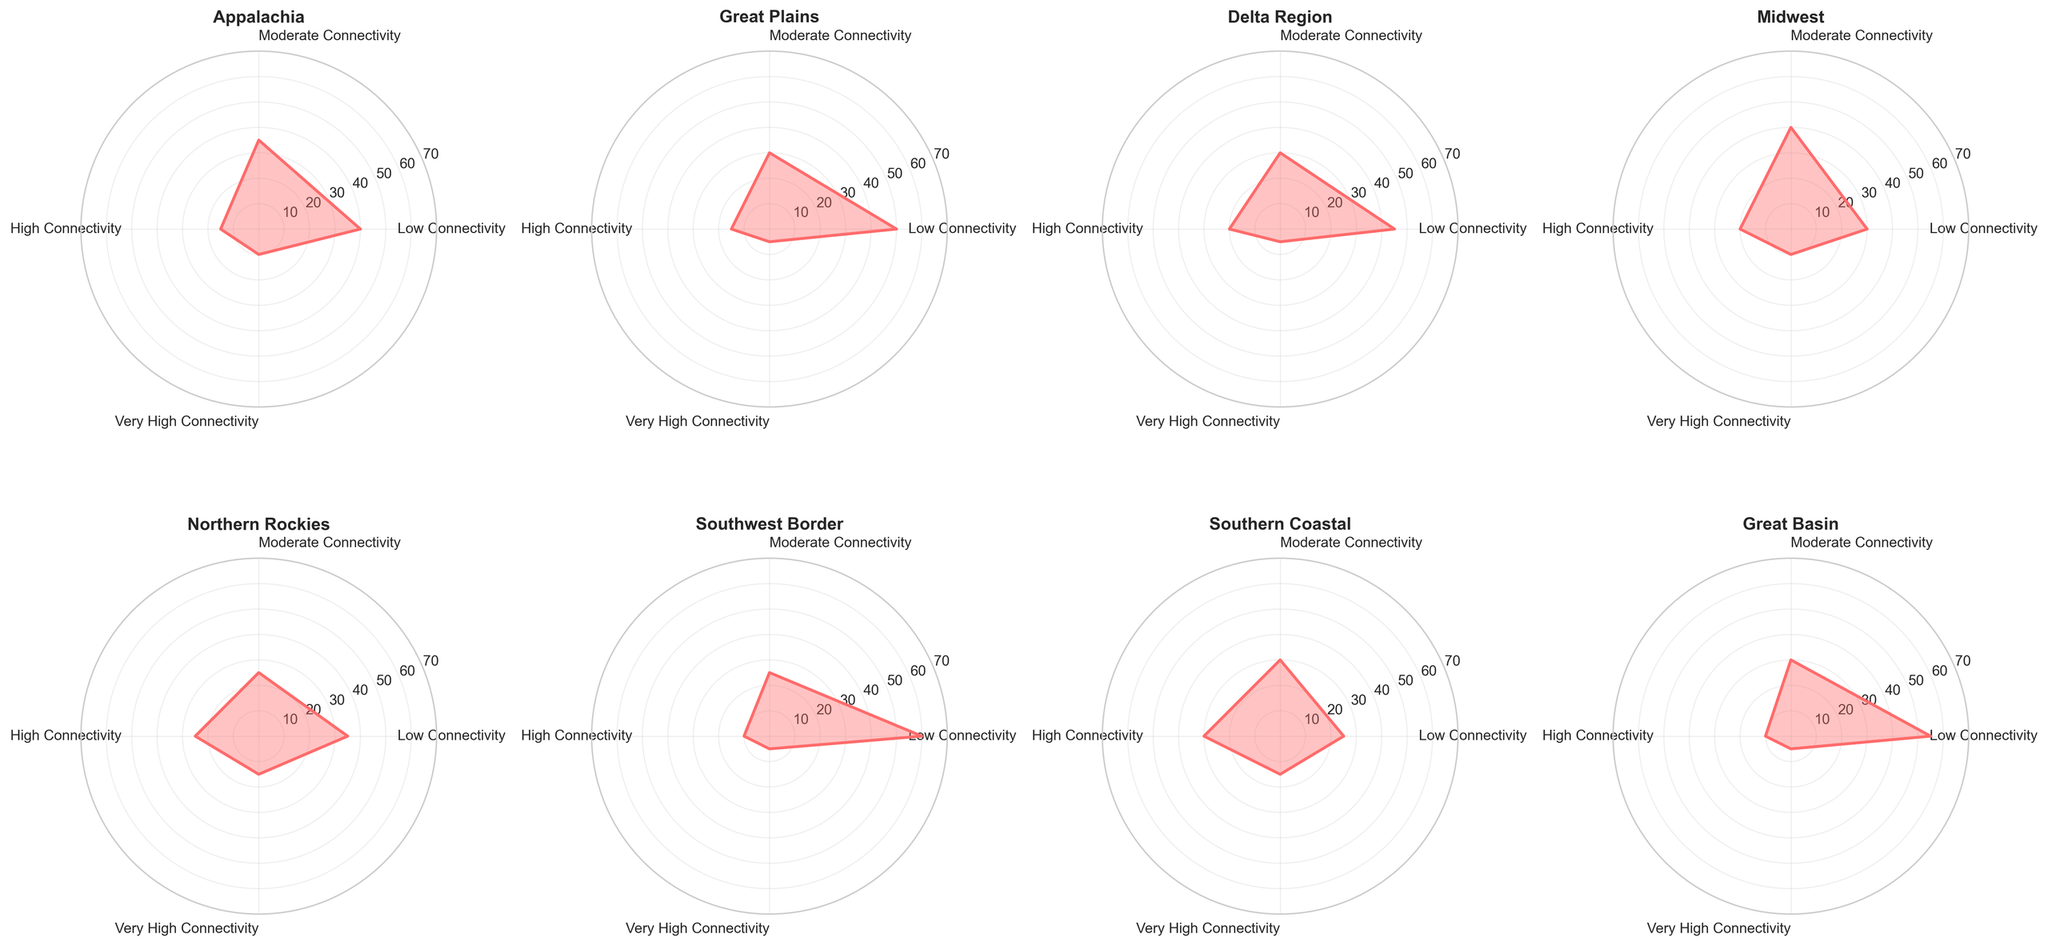How many regions are displayed in the figure? By counting the titles of the subplots, we see there are 8 different regions: Appalachia, Great Plains, Delta Region, Midwest, Northern Rockies, Southwest Border, Southern Coastal, and Great Basin.
Answer: 8 Which region has the highest percentage of Low Connectivity? To find the highest percentage of Low Connectivity, look at the values or bars for each region. Southwest Border has the highest with 60%.
Answer: Southwest Border Which two regions have equal percentages of Very High Connectivity? By checking the Very High Connectivity values for all regions, both Midwest and Southern Coastal have 10%.
Answer: Midwest and Southern Coastal What is the pattern of Moderate Connectivity in the Delta Region? By examining the Delta Region subplot, you see the Moderate Connectivity is at 30%. This can be read directly from the respective part of the rose chart.
Answer: 30% For Northern Rockies, what are the values of High and Very High Connectivity combined? High Connectivity is 25% and Very High Connectivity is 15%. Adding these together gives 25 + 15 = 40%.
Answer: 40% Which region has the lowest percentage of Moderate Connectivity? By looking at the bars for Moderate Connectivity across all regions, Northern Rockies has the lowest with 25%.
Answer: Northern Rockies How does Appalachian Low Connectivity compare to Southern Coastal Low Connectivity? Appalachia's Low Connectivity is at 40% while Southern Coastal is at 25%. Thus, Appalachia's Low Connectivity is higher.
Answer: Higher In which region is there a higher percentage of High Connectivity, Midwest or Northern Rockies? For Midwest, High Connectivity is 20%, and for Northern Rockies, it's 25%. Hence, Northern Rockies has a higher percentage of High Connectivity.
Answer: Northern Rockies Considering combined High and Moderate Connectivity, which region shows the most connectivity? Add the High and Moderate Connectivity percentages for each region. The region with the highest combined value is Southern Coastal with 30% + 30% = 60%.
Answer: Southern Coastal 